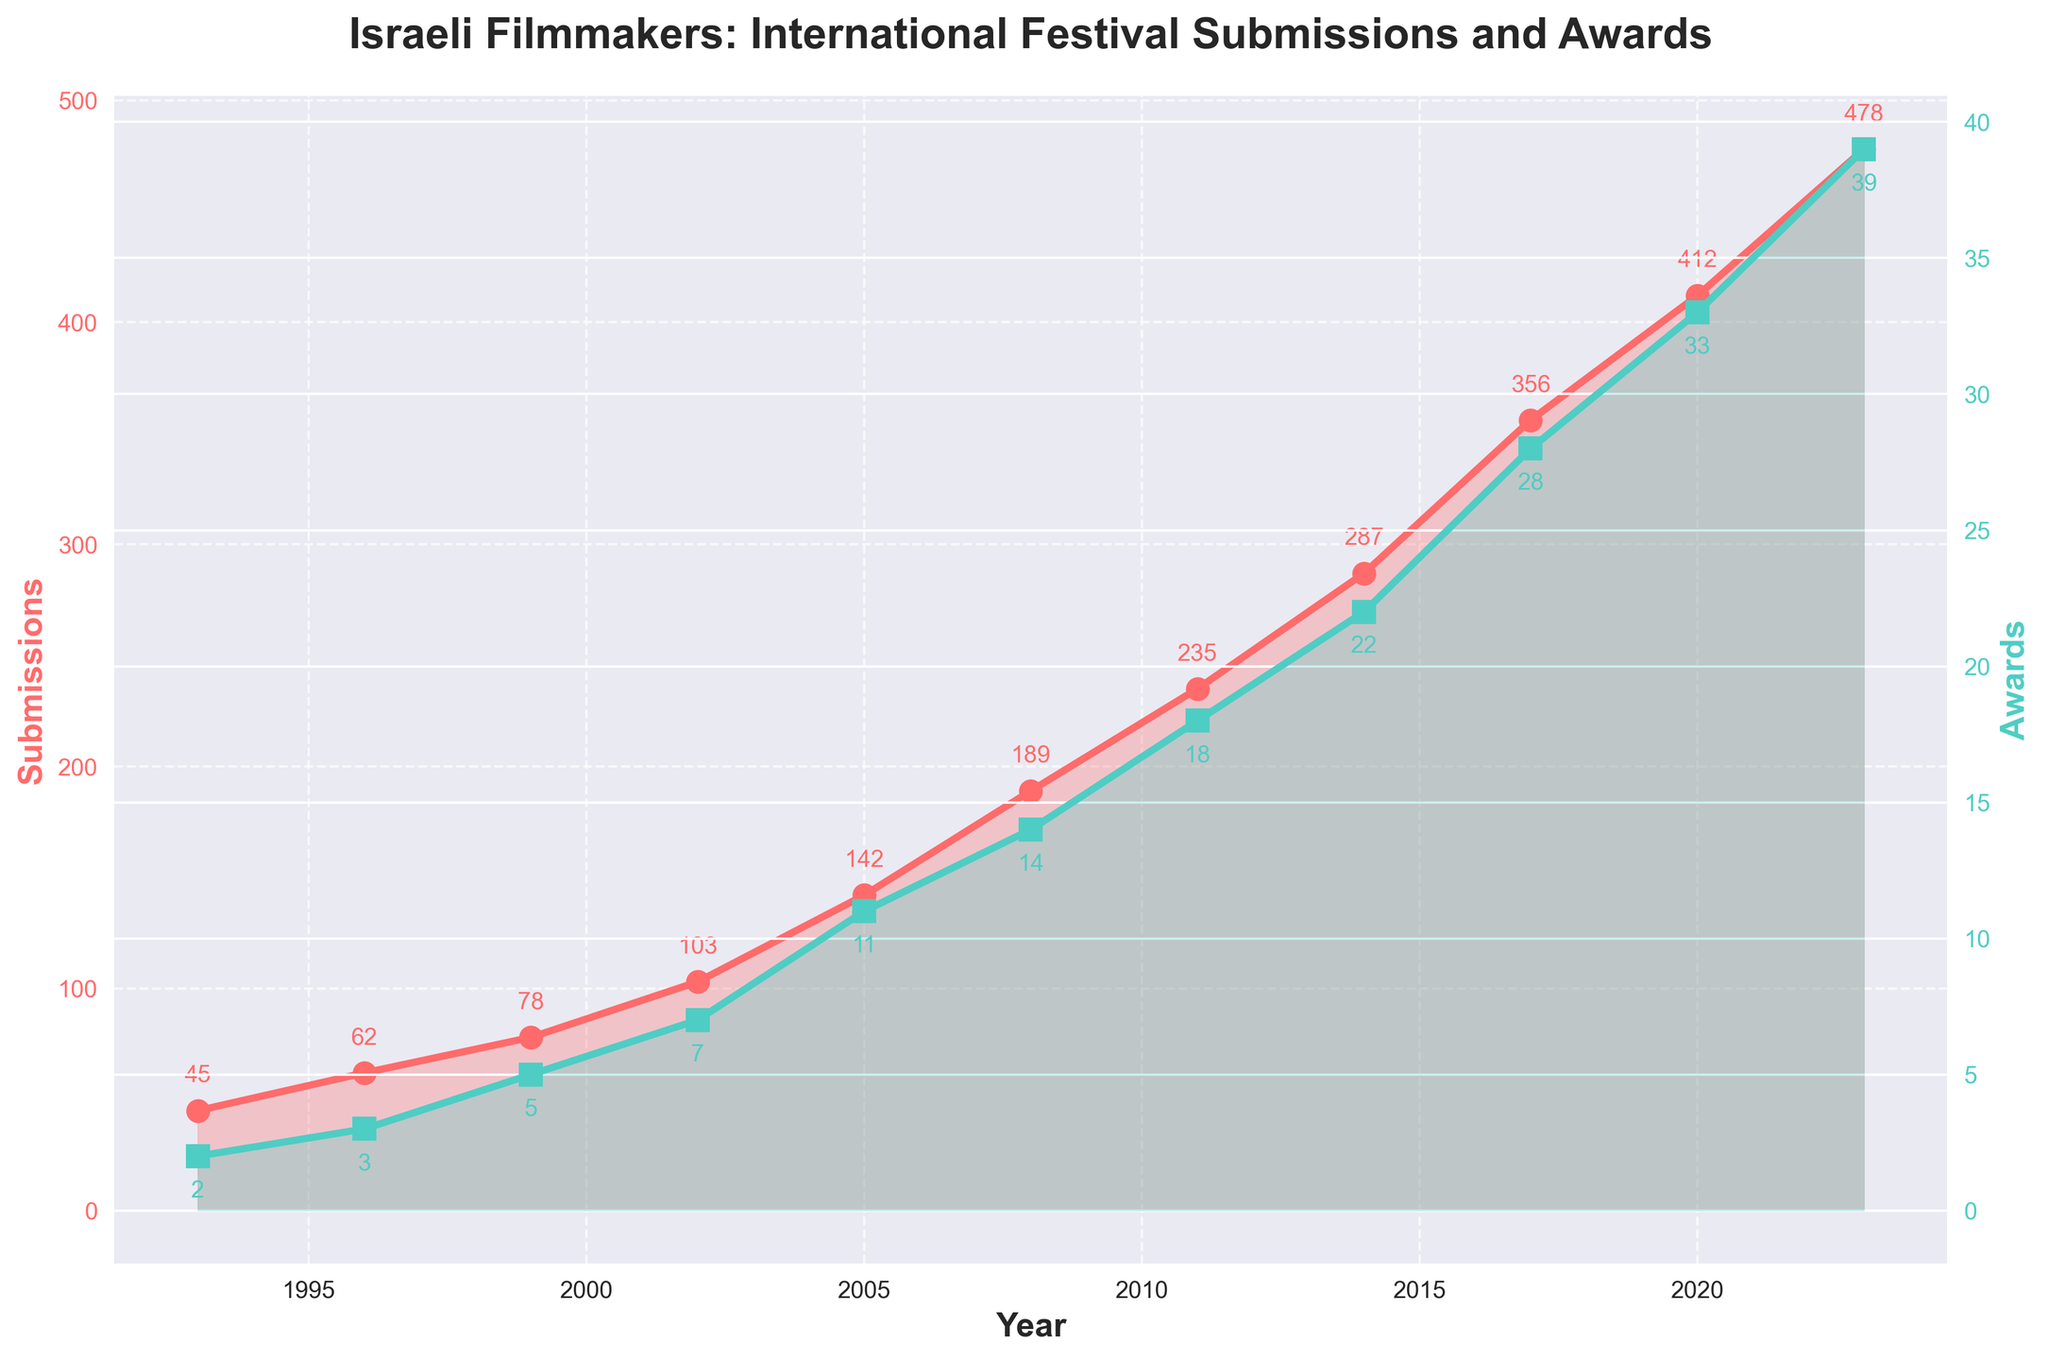What's the trend in submissions from 1993 to 2023? The data shows the number of submissions increasing steadily from 45 in 1993 to 478 in 2023. This indicates a consistent upward trend over the 30-year period.
Answer: Increasing trend How many awards were won by Israeli filmmakers in 2011? From the dataset, Israeli filmmakers won 18 awards in 2011. This is directly shown on the chart.
Answer: 18 What is the difference in the number of submissions between 2005 and 2014? The number of submissions in 2005 was 142 and in 2014 it was 287. The difference is 287 - 142 = 145.
Answer: 145 In which year did the number of awards first exceed 20? By examining the chart, the number of awards first exceeds 20 in 2014 when it reached 22.
Answer: 2014 How does the number of submissions in 2020 compare to that in 2017? The number of submissions in 2020 was 412, while in 2017 it was 356. Comparing these, 412 is greater than 356.
Answer: Greater in 2020 What is the average number of awards per year from 1993 to 2023? To find the average, sum all the awards (2 + 3 + 5 + 7 + 11 + 14 + 18 + 22 + 28 + 33 + 39 = 182) and divide by the number of years (11). The average number of awards per year is 182 / 11 = 16.55.
Answer: 16.55 Compare the visual difference in the height of the lines representing submissions and awards in the plot. The line representing submissions (red) is generally higher across the years compared to the line representing awards (green), indicating higher values for submissions compared to awards.
Answer: Submissions line is higher How much has the number of submissions increased from 1993 to 2023? The number of submissions in 1993 was 45 and in 2023 it was 478. The increase is 478 - 45 = 433.
Answer: 433 During which three-year span was there the greatest increase in submissions? By examining the increments between years, the greatest increase appears to be from 2017 (356 submissions) to 2020 (412 submissions), amounting to 412 - 356 = 56 submissions.
Answer: 2017 to 2020 What color represents the number of awards in the plot? The line representing the number of awards is green. This is directly observed from the chart.
Answer: Green 